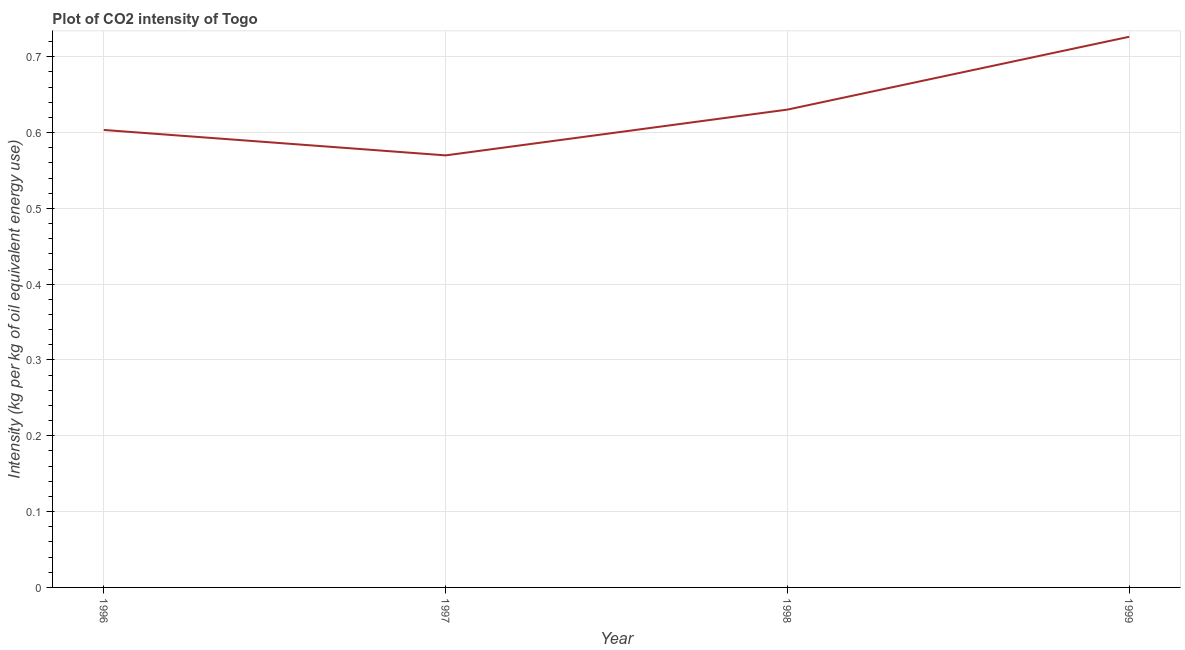What is the co2 intensity in 1999?
Make the answer very short. 0.73. Across all years, what is the maximum co2 intensity?
Offer a terse response. 0.73. Across all years, what is the minimum co2 intensity?
Your answer should be compact. 0.57. In which year was the co2 intensity minimum?
Offer a terse response. 1997. What is the sum of the co2 intensity?
Provide a succinct answer. 2.53. What is the difference between the co2 intensity in 1997 and 1998?
Provide a succinct answer. -0.06. What is the average co2 intensity per year?
Make the answer very short. 0.63. What is the median co2 intensity?
Offer a very short reply. 0.62. In how many years, is the co2 intensity greater than 0.28 kg?
Offer a very short reply. 4. Do a majority of the years between 1999 and 1996 (inclusive) have co2 intensity greater than 0.68 kg?
Your response must be concise. Yes. What is the ratio of the co2 intensity in 1996 to that in 1998?
Ensure brevity in your answer.  0.96. Is the co2 intensity in 1997 less than that in 1999?
Make the answer very short. Yes. Is the difference between the co2 intensity in 1998 and 1999 greater than the difference between any two years?
Keep it short and to the point. No. What is the difference between the highest and the second highest co2 intensity?
Your answer should be compact. 0.1. Is the sum of the co2 intensity in 1996 and 1999 greater than the maximum co2 intensity across all years?
Make the answer very short. Yes. What is the difference between the highest and the lowest co2 intensity?
Your answer should be very brief. 0.16. In how many years, is the co2 intensity greater than the average co2 intensity taken over all years?
Ensure brevity in your answer.  1. How many lines are there?
Your response must be concise. 1. How many years are there in the graph?
Provide a short and direct response. 4. Are the values on the major ticks of Y-axis written in scientific E-notation?
Keep it short and to the point. No. Does the graph contain any zero values?
Your answer should be compact. No. Does the graph contain grids?
Your response must be concise. Yes. What is the title of the graph?
Keep it short and to the point. Plot of CO2 intensity of Togo. What is the label or title of the X-axis?
Keep it short and to the point. Year. What is the label or title of the Y-axis?
Give a very brief answer. Intensity (kg per kg of oil equivalent energy use). What is the Intensity (kg per kg of oil equivalent energy use) of 1996?
Make the answer very short. 0.6. What is the Intensity (kg per kg of oil equivalent energy use) of 1997?
Your answer should be compact. 0.57. What is the Intensity (kg per kg of oil equivalent energy use) in 1998?
Ensure brevity in your answer.  0.63. What is the Intensity (kg per kg of oil equivalent energy use) of 1999?
Your response must be concise. 0.73. What is the difference between the Intensity (kg per kg of oil equivalent energy use) in 1996 and 1997?
Make the answer very short. 0.03. What is the difference between the Intensity (kg per kg of oil equivalent energy use) in 1996 and 1998?
Your response must be concise. -0.03. What is the difference between the Intensity (kg per kg of oil equivalent energy use) in 1996 and 1999?
Keep it short and to the point. -0.12. What is the difference between the Intensity (kg per kg of oil equivalent energy use) in 1997 and 1998?
Your answer should be compact. -0.06. What is the difference between the Intensity (kg per kg of oil equivalent energy use) in 1997 and 1999?
Offer a very short reply. -0.16. What is the difference between the Intensity (kg per kg of oil equivalent energy use) in 1998 and 1999?
Make the answer very short. -0.1. What is the ratio of the Intensity (kg per kg of oil equivalent energy use) in 1996 to that in 1997?
Give a very brief answer. 1.06. What is the ratio of the Intensity (kg per kg of oil equivalent energy use) in 1996 to that in 1999?
Ensure brevity in your answer.  0.83. What is the ratio of the Intensity (kg per kg of oil equivalent energy use) in 1997 to that in 1998?
Your response must be concise. 0.9. What is the ratio of the Intensity (kg per kg of oil equivalent energy use) in 1997 to that in 1999?
Your response must be concise. 0.79. What is the ratio of the Intensity (kg per kg of oil equivalent energy use) in 1998 to that in 1999?
Keep it short and to the point. 0.87. 